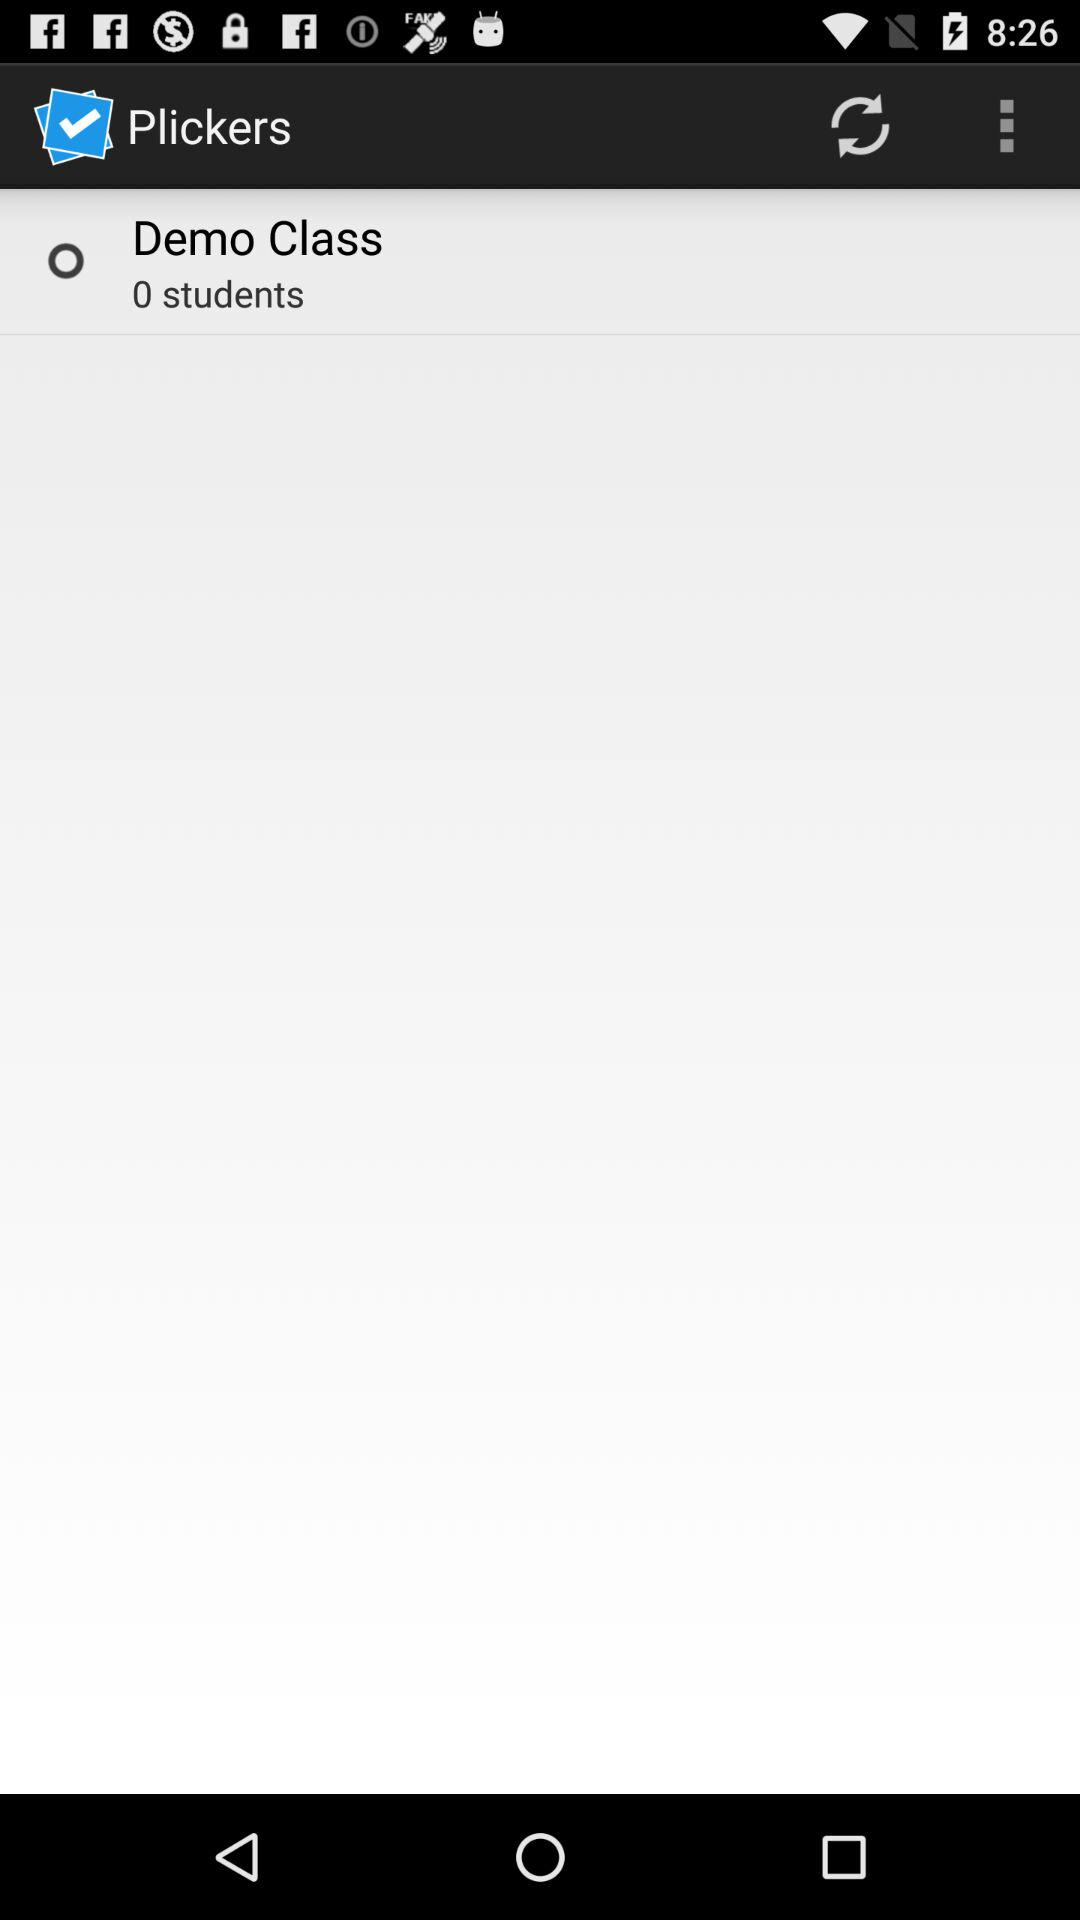How many students are in the demo class? There are 0 students. 